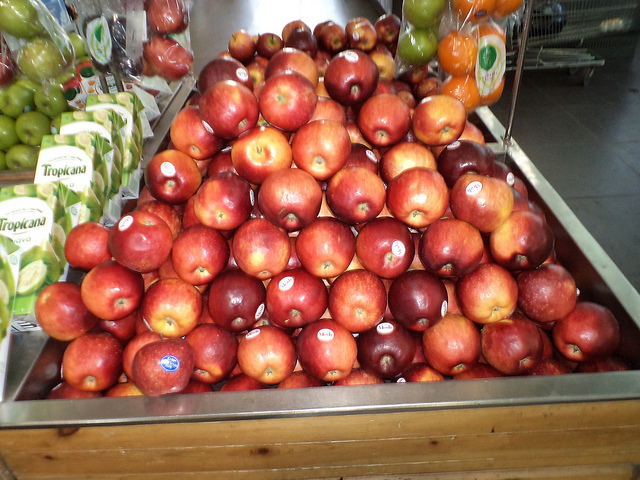Please extract the text content from this image. Tropicana 